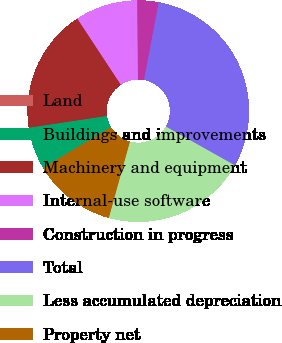Convert chart to OTSL. <chart><loc_0><loc_0><loc_500><loc_500><pie_chart><fcel>Land<fcel>Buildings and improvements<fcel>Machinery and equipment<fcel>Internal-use software<fcel>Construction in progress<fcel>Total<fcel>Less accumulated depreciation<fcel>Property net<nl><fcel>0.08%<fcel>6.11%<fcel>18.13%<fcel>9.12%<fcel>3.1%<fcel>30.2%<fcel>21.14%<fcel>12.13%<nl></chart> 